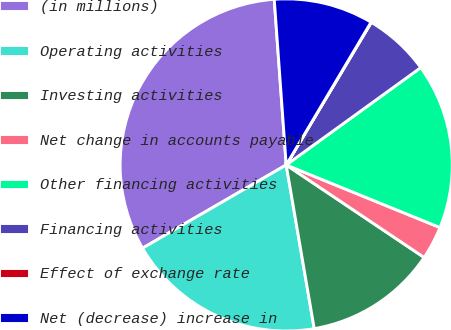Convert chart. <chart><loc_0><loc_0><loc_500><loc_500><pie_chart><fcel>(in millions)<fcel>Operating activities<fcel>Investing activities<fcel>Net change in accounts payable<fcel>Other financing activities<fcel>Financing activities<fcel>Effect of exchange rate<fcel>Net (decrease) increase in<nl><fcel>32.21%<fcel>19.34%<fcel>12.9%<fcel>3.25%<fcel>16.12%<fcel>6.47%<fcel>0.03%<fcel>9.68%<nl></chart> 